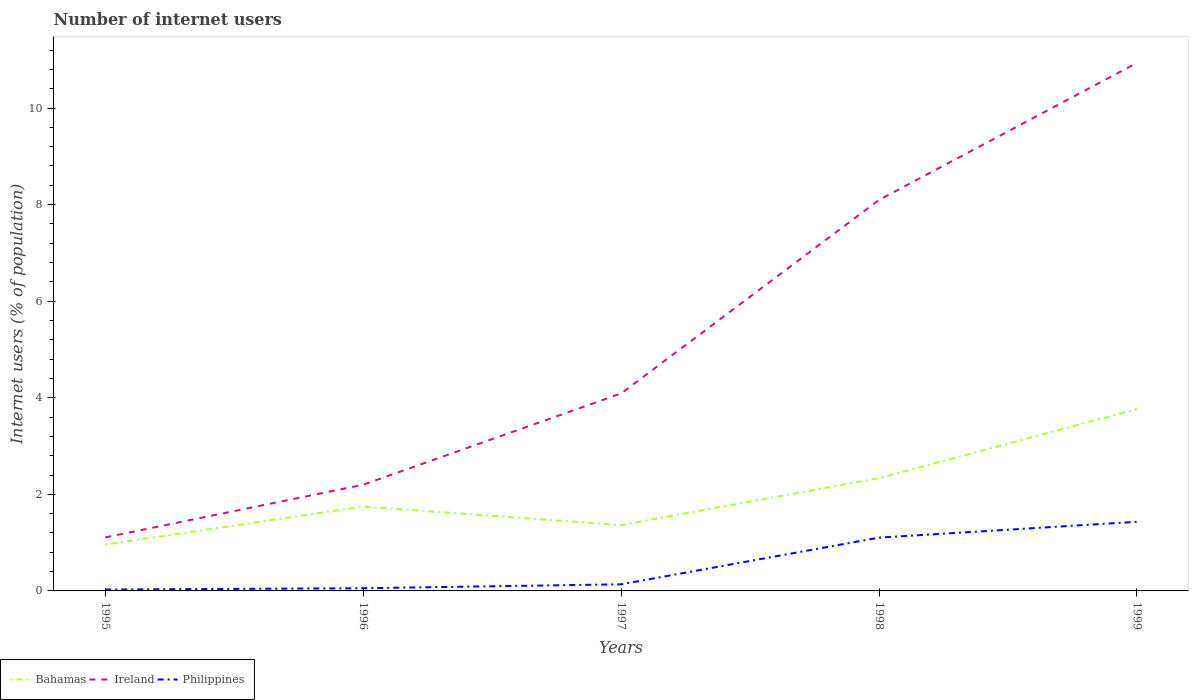How many different coloured lines are there?
Keep it short and to the point. 3. Is the number of lines equal to the number of legend labels?
Give a very brief answer. Yes. Across all years, what is the maximum number of internet users in Philippines?
Offer a terse response. 0.03. In which year was the number of internet users in Philippines maximum?
Provide a succinct answer. 1995. What is the total number of internet users in Philippines in the graph?
Your answer should be compact. -1.07. What is the difference between the highest and the second highest number of internet users in Ireland?
Provide a short and direct response. 9.83. What is the difference between the highest and the lowest number of internet users in Philippines?
Provide a short and direct response. 2. Is the number of internet users in Philippines strictly greater than the number of internet users in Bahamas over the years?
Keep it short and to the point. Yes. Does the graph contain any zero values?
Provide a short and direct response. No. Where does the legend appear in the graph?
Offer a very short reply. Bottom left. How many legend labels are there?
Keep it short and to the point. 3. What is the title of the graph?
Give a very brief answer. Number of internet users. What is the label or title of the X-axis?
Your response must be concise. Years. What is the label or title of the Y-axis?
Offer a very short reply. Internet users (% of population). What is the Internet users (% of population) in Bahamas in 1995?
Make the answer very short. 0.96. What is the Internet users (% of population) of Ireland in 1995?
Offer a very short reply. 1.11. What is the Internet users (% of population) in Philippines in 1995?
Your answer should be compact. 0.03. What is the Internet users (% of population) in Bahamas in 1996?
Your response must be concise. 1.75. What is the Internet users (% of population) in Ireland in 1996?
Offer a terse response. 2.2. What is the Internet users (% of population) of Philippines in 1996?
Your answer should be very brief. 0.06. What is the Internet users (% of population) of Bahamas in 1997?
Your answer should be compact. 1.36. What is the Internet users (% of population) in Ireland in 1997?
Keep it short and to the point. 4.09. What is the Internet users (% of population) of Philippines in 1997?
Offer a very short reply. 0.14. What is the Internet users (% of population) in Bahamas in 1998?
Keep it short and to the point. 2.34. What is the Internet users (% of population) of Ireland in 1998?
Keep it short and to the point. 8.1. What is the Internet users (% of population) in Philippines in 1998?
Your answer should be very brief. 1.1. What is the Internet users (% of population) of Bahamas in 1999?
Ensure brevity in your answer.  3.76. What is the Internet users (% of population) in Ireland in 1999?
Offer a very short reply. 10.93. What is the Internet users (% of population) in Philippines in 1999?
Give a very brief answer. 1.43. Across all years, what is the maximum Internet users (% of population) of Bahamas?
Give a very brief answer. 3.76. Across all years, what is the maximum Internet users (% of population) in Ireland?
Your answer should be compact. 10.93. Across all years, what is the maximum Internet users (% of population) of Philippines?
Keep it short and to the point. 1.43. Across all years, what is the minimum Internet users (% of population) in Bahamas?
Provide a succinct answer. 0.96. Across all years, what is the minimum Internet users (% of population) of Ireland?
Offer a terse response. 1.11. Across all years, what is the minimum Internet users (% of population) of Philippines?
Your answer should be compact. 0.03. What is the total Internet users (% of population) of Bahamas in the graph?
Provide a short and direct response. 10.17. What is the total Internet users (% of population) in Ireland in the graph?
Your answer should be very brief. 26.43. What is the total Internet users (% of population) of Philippines in the graph?
Keep it short and to the point. 2.76. What is the difference between the Internet users (% of population) in Bahamas in 1995 and that in 1996?
Your answer should be compact. -0.79. What is the difference between the Internet users (% of population) in Ireland in 1995 and that in 1996?
Give a very brief answer. -1.09. What is the difference between the Internet users (% of population) of Philippines in 1995 and that in 1996?
Keep it short and to the point. -0.03. What is the difference between the Internet users (% of population) in Bahamas in 1995 and that in 1997?
Your response must be concise. -0.4. What is the difference between the Internet users (% of population) in Ireland in 1995 and that in 1997?
Your answer should be compact. -2.98. What is the difference between the Internet users (% of population) of Philippines in 1995 and that in 1997?
Keep it short and to the point. -0.11. What is the difference between the Internet users (% of population) in Bahamas in 1995 and that in 1998?
Give a very brief answer. -1.38. What is the difference between the Internet users (% of population) of Ireland in 1995 and that in 1998?
Keep it short and to the point. -6.99. What is the difference between the Internet users (% of population) of Philippines in 1995 and that in 1998?
Make the answer very short. -1.07. What is the difference between the Internet users (% of population) in Bahamas in 1995 and that in 1999?
Provide a short and direct response. -2.8. What is the difference between the Internet users (% of population) in Ireland in 1995 and that in 1999?
Ensure brevity in your answer.  -9.83. What is the difference between the Internet users (% of population) of Philippines in 1995 and that in 1999?
Your answer should be very brief. -1.4. What is the difference between the Internet users (% of population) of Bahamas in 1996 and that in 1997?
Ensure brevity in your answer.  0.38. What is the difference between the Internet users (% of population) in Ireland in 1996 and that in 1997?
Ensure brevity in your answer.  -1.89. What is the difference between the Internet users (% of population) in Philippines in 1996 and that in 1997?
Ensure brevity in your answer.  -0.08. What is the difference between the Internet users (% of population) of Bahamas in 1996 and that in 1998?
Provide a short and direct response. -0.59. What is the difference between the Internet users (% of population) in Ireland in 1996 and that in 1998?
Provide a short and direct response. -5.9. What is the difference between the Internet users (% of population) of Philippines in 1996 and that in 1998?
Give a very brief answer. -1.05. What is the difference between the Internet users (% of population) in Bahamas in 1996 and that in 1999?
Your answer should be compact. -2.02. What is the difference between the Internet users (% of population) of Ireland in 1996 and that in 1999?
Provide a succinct answer. -8.73. What is the difference between the Internet users (% of population) in Philippines in 1996 and that in 1999?
Your response must be concise. -1.38. What is the difference between the Internet users (% of population) of Bahamas in 1997 and that in 1998?
Your answer should be very brief. -0.97. What is the difference between the Internet users (% of population) in Ireland in 1997 and that in 1998?
Ensure brevity in your answer.  -4.01. What is the difference between the Internet users (% of population) in Philippines in 1997 and that in 1998?
Offer a terse response. -0.97. What is the difference between the Internet users (% of population) in Bahamas in 1997 and that in 1999?
Your answer should be compact. -2.4. What is the difference between the Internet users (% of population) of Ireland in 1997 and that in 1999?
Keep it short and to the point. -6.85. What is the difference between the Internet users (% of population) in Philippines in 1997 and that in 1999?
Offer a very short reply. -1.29. What is the difference between the Internet users (% of population) of Bahamas in 1998 and that in 1999?
Offer a very short reply. -1.43. What is the difference between the Internet users (% of population) of Ireland in 1998 and that in 1999?
Your answer should be very brief. -2.84. What is the difference between the Internet users (% of population) of Philippines in 1998 and that in 1999?
Provide a short and direct response. -0.33. What is the difference between the Internet users (% of population) of Bahamas in 1995 and the Internet users (% of population) of Ireland in 1996?
Offer a very short reply. -1.24. What is the difference between the Internet users (% of population) of Bahamas in 1995 and the Internet users (% of population) of Philippines in 1996?
Keep it short and to the point. 0.9. What is the difference between the Internet users (% of population) of Ireland in 1995 and the Internet users (% of population) of Philippines in 1996?
Provide a short and direct response. 1.05. What is the difference between the Internet users (% of population) in Bahamas in 1995 and the Internet users (% of population) in Ireland in 1997?
Provide a succinct answer. -3.13. What is the difference between the Internet users (% of population) in Bahamas in 1995 and the Internet users (% of population) in Philippines in 1997?
Provide a short and direct response. 0.82. What is the difference between the Internet users (% of population) of Ireland in 1995 and the Internet users (% of population) of Philippines in 1997?
Ensure brevity in your answer.  0.97. What is the difference between the Internet users (% of population) of Bahamas in 1995 and the Internet users (% of population) of Ireland in 1998?
Ensure brevity in your answer.  -7.14. What is the difference between the Internet users (% of population) of Bahamas in 1995 and the Internet users (% of population) of Philippines in 1998?
Offer a very short reply. -0.14. What is the difference between the Internet users (% of population) of Ireland in 1995 and the Internet users (% of population) of Philippines in 1998?
Your answer should be compact. 0.01. What is the difference between the Internet users (% of population) of Bahamas in 1995 and the Internet users (% of population) of Ireland in 1999?
Your answer should be compact. -9.97. What is the difference between the Internet users (% of population) of Bahamas in 1995 and the Internet users (% of population) of Philippines in 1999?
Give a very brief answer. -0.47. What is the difference between the Internet users (% of population) in Ireland in 1995 and the Internet users (% of population) in Philippines in 1999?
Ensure brevity in your answer.  -0.32. What is the difference between the Internet users (% of population) of Bahamas in 1996 and the Internet users (% of population) of Ireland in 1997?
Keep it short and to the point. -2.34. What is the difference between the Internet users (% of population) of Bahamas in 1996 and the Internet users (% of population) of Philippines in 1997?
Ensure brevity in your answer.  1.61. What is the difference between the Internet users (% of population) in Ireland in 1996 and the Internet users (% of population) in Philippines in 1997?
Offer a terse response. 2.06. What is the difference between the Internet users (% of population) in Bahamas in 1996 and the Internet users (% of population) in Ireland in 1998?
Ensure brevity in your answer.  -6.35. What is the difference between the Internet users (% of population) of Bahamas in 1996 and the Internet users (% of population) of Philippines in 1998?
Make the answer very short. 0.64. What is the difference between the Internet users (% of population) in Ireland in 1996 and the Internet users (% of population) in Philippines in 1998?
Give a very brief answer. 1.1. What is the difference between the Internet users (% of population) of Bahamas in 1996 and the Internet users (% of population) of Ireland in 1999?
Your answer should be very brief. -9.19. What is the difference between the Internet users (% of population) of Bahamas in 1996 and the Internet users (% of population) of Philippines in 1999?
Give a very brief answer. 0.32. What is the difference between the Internet users (% of population) of Ireland in 1996 and the Internet users (% of population) of Philippines in 1999?
Ensure brevity in your answer.  0.77. What is the difference between the Internet users (% of population) in Bahamas in 1997 and the Internet users (% of population) in Ireland in 1998?
Provide a succinct answer. -6.73. What is the difference between the Internet users (% of population) of Bahamas in 1997 and the Internet users (% of population) of Philippines in 1998?
Make the answer very short. 0.26. What is the difference between the Internet users (% of population) of Ireland in 1997 and the Internet users (% of population) of Philippines in 1998?
Offer a very short reply. 2.98. What is the difference between the Internet users (% of population) in Bahamas in 1997 and the Internet users (% of population) in Ireland in 1999?
Your answer should be compact. -9.57. What is the difference between the Internet users (% of population) in Bahamas in 1997 and the Internet users (% of population) in Philippines in 1999?
Make the answer very short. -0.07. What is the difference between the Internet users (% of population) of Ireland in 1997 and the Internet users (% of population) of Philippines in 1999?
Make the answer very short. 2.66. What is the difference between the Internet users (% of population) in Bahamas in 1998 and the Internet users (% of population) in Ireland in 1999?
Provide a short and direct response. -8.6. What is the difference between the Internet users (% of population) in Bahamas in 1998 and the Internet users (% of population) in Philippines in 1999?
Your answer should be compact. 0.9. What is the difference between the Internet users (% of population) in Ireland in 1998 and the Internet users (% of population) in Philippines in 1999?
Keep it short and to the point. 6.66. What is the average Internet users (% of population) in Bahamas per year?
Your answer should be very brief. 2.03. What is the average Internet users (% of population) in Ireland per year?
Keep it short and to the point. 5.29. What is the average Internet users (% of population) of Philippines per year?
Give a very brief answer. 0.55. In the year 1995, what is the difference between the Internet users (% of population) in Bahamas and Internet users (% of population) in Ireland?
Provide a short and direct response. -0.15. In the year 1995, what is the difference between the Internet users (% of population) of Bahamas and Internet users (% of population) of Philippines?
Make the answer very short. 0.93. In the year 1995, what is the difference between the Internet users (% of population) of Ireland and Internet users (% of population) of Philippines?
Provide a short and direct response. 1.08. In the year 1996, what is the difference between the Internet users (% of population) in Bahamas and Internet users (% of population) in Ireland?
Keep it short and to the point. -0.45. In the year 1996, what is the difference between the Internet users (% of population) of Bahamas and Internet users (% of population) of Philippines?
Your response must be concise. 1.69. In the year 1996, what is the difference between the Internet users (% of population) of Ireland and Internet users (% of population) of Philippines?
Your answer should be very brief. 2.14. In the year 1997, what is the difference between the Internet users (% of population) of Bahamas and Internet users (% of population) of Ireland?
Keep it short and to the point. -2.73. In the year 1997, what is the difference between the Internet users (% of population) of Bahamas and Internet users (% of population) of Philippines?
Give a very brief answer. 1.23. In the year 1997, what is the difference between the Internet users (% of population) in Ireland and Internet users (% of population) in Philippines?
Ensure brevity in your answer.  3.95. In the year 1998, what is the difference between the Internet users (% of population) in Bahamas and Internet users (% of population) in Ireland?
Offer a very short reply. -5.76. In the year 1998, what is the difference between the Internet users (% of population) in Bahamas and Internet users (% of population) in Philippines?
Your answer should be very brief. 1.23. In the year 1998, what is the difference between the Internet users (% of population) of Ireland and Internet users (% of population) of Philippines?
Give a very brief answer. 6.99. In the year 1999, what is the difference between the Internet users (% of population) of Bahamas and Internet users (% of population) of Ireland?
Provide a succinct answer. -7.17. In the year 1999, what is the difference between the Internet users (% of population) in Bahamas and Internet users (% of population) in Philippines?
Your answer should be compact. 2.33. In the year 1999, what is the difference between the Internet users (% of population) in Ireland and Internet users (% of population) in Philippines?
Offer a very short reply. 9.5. What is the ratio of the Internet users (% of population) of Bahamas in 1995 to that in 1996?
Give a very brief answer. 0.55. What is the ratio of the Internet users (% of population) in Ireland in 1995 to that in 1996?
Your answer should be compact. 0.5. What is the ratio of the Internet users (% of population) of Philippines in 1995 to that in 1996?
Give a very brief answer. 0.51. What is the ratio of the Internet users (% of population) in Bahamas in 1995 to that in 1997?
Offer a very short reply. 0.7. What is the ratio of the Internet users (% of population) of Ireland in 1995 to that in 1997?
Provide a short and direct response. 0.27. What is the ratio of the Internet users (% of population) in Philippines in 1995 to that in 1997?
Provide a succinct answer. 0.21. What is the ratio of the Internet users (% of population) of Bahamas in 1995 to that in 1998?
Offer a terse response. 0.41. What is the ratio of the Internet users (% of population) in Ireland in 1995 to that in 1998?
Offer a terse response. 0.14. What is the ratio of the Internet users (% of population) of Philippines in 1995 to that in 1998?
Your response must be concise. 0.03. What is the ratio of the Internet users (% of population) of Bahamas in 1995 to that in 1999?
Give a very brief answer. 0.26. What is the ratio of the Internet users (% of population) in Ireland in 1995 to that in 1999?
Your answer should be very brief. 0.1. What is the ratio of the Internet users (% of population) in Philippines in 1995 to that in 1999?
Your answer should be very brief. 0.02. What is the ratio of the Internet users (% of population) of Bahamas in 1996 to that in 1997?
Keep it short and to the point. 1.28. What is the ratio of the Internet users (% of population) in Ireland in 1996 to that in 1997?
Ensure brevity in your answer.  0.54. What is the ratio of the Internet users (% of population) of Philippines in 1996 to that in 1997?
Make the answer very short. 0.41. What is the ratio of the Internet users (% of population) of Bahamas in 1996 to that in 1998?
Offer a terse response. 0.75. What is the ratio of the Internet users (% of population) of Ireland in 1996 to that in 1998?
Your response must be concise. 0.27. What is the ratio of the Internet users (% of population) of Philippines in 1996 to that in 1998?
Make the answer very short. 0.05. What is the ratio of the Internet users (% of population) of Bahamas in 1996 to that in 1999?
Make the answer very short. 0.46. What is the ratio of the Internet users (% of population) in Ireland in 1996 to that in 1999?
Ensure brevity in your answer.  0.2. What is the ratio of the Internet users (% of population) of Philippines in 1996 to that in 1999?
Offer a terse response. 0.04. What is the ratio of the Internet users (% of population) of Bahamas in 1997 to that in 1998?
Your response must be concise. 0.58. What is the ratio of the Internet users (% of population) of Ireland in 1997 to that in 1998?
Provide a short and direct response. 0.51. What is the ratio of the Internet users (% of population) of Philippines in 1997 to that in 1998?
Keep it short and to the point. 0.12. What is the ratio of the Internet users (% of population) in Bahamas in 1997 to that in 1999?
Provide a short and direct response. 0.36. What is the ratio of the Internet users (% of population) in Ireland in 1997 to that in 1999?
Give a very brief answer. 0.37. What is the ratio of the Internet users (% of population) of Philippines in 1997 to that in 1999?
Provide a succinct answer. 0.1. What is the ratio of the Internet users (% of population) in Bahamas in 1998 to that in 1999?
Your answer should be compact. 0.62. What is the ratio of the Internet users (% of population) in Ireland in 1998 to that in 1999?
Your response must be concise. 0.74. What is the ratio of the Internet users (% of population) in Philippines in 1998 to that in 1999?
Keep it short and to the point. 0.77. What is the difference between the highest and the second highest Internet users (% of population) in Bahamas?
Provide a short and direct response. 1.43. What is the difference between the highest and the second highest Internet users (% of population) in Ireland?
Give a very brief answer. 2.84. What is the difference between the highest and the second highest Internet users (% of population) in Philippines?
Provide a short and direct response. 0.33. What is the difference between the highest and the lowest Internet users (% of population) of Bahamas?
Your answer should be very brief. 2.8. What is the difference between the highest and the lowest Internet users (% of population) of Ireland?
Your answer should be compact. 9.83. What is the difference between the highest and the lowest Internet users (% of population) in Philippines?
Keep it short and to the point. 1.4. 